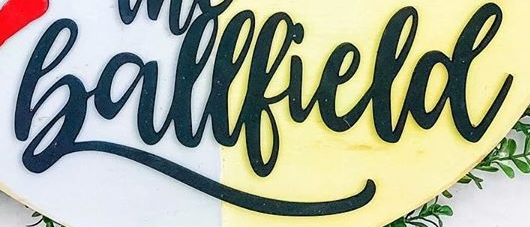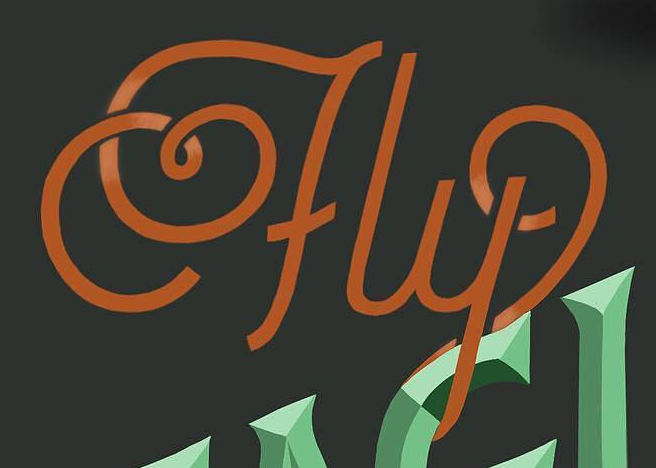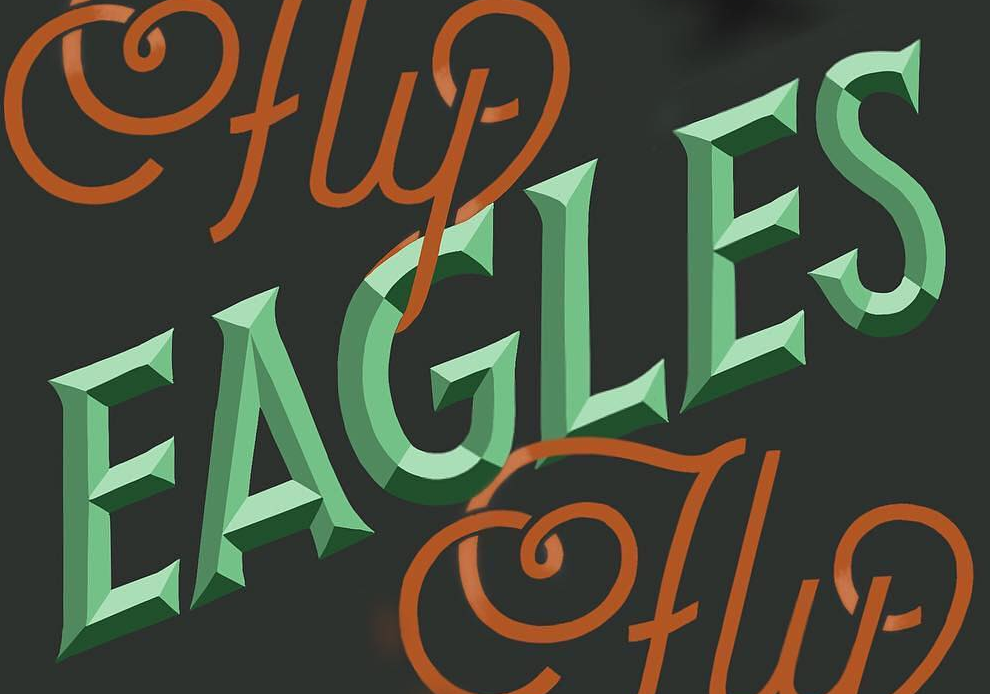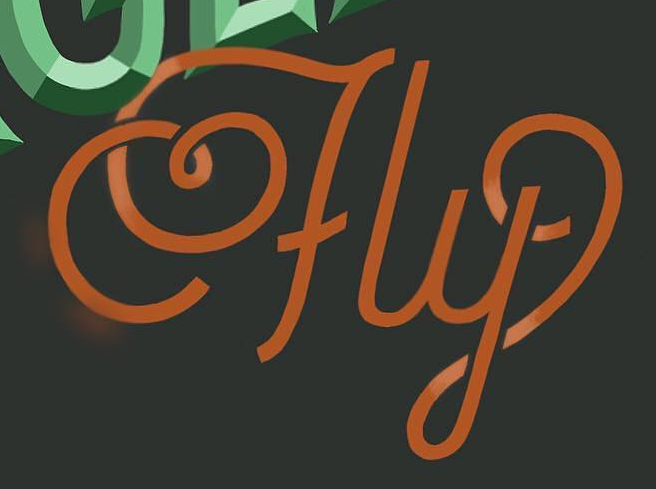Transcribe the words shown in these images in order, separated by a semicolon. Ballfield; fly; EAGLES; fly 